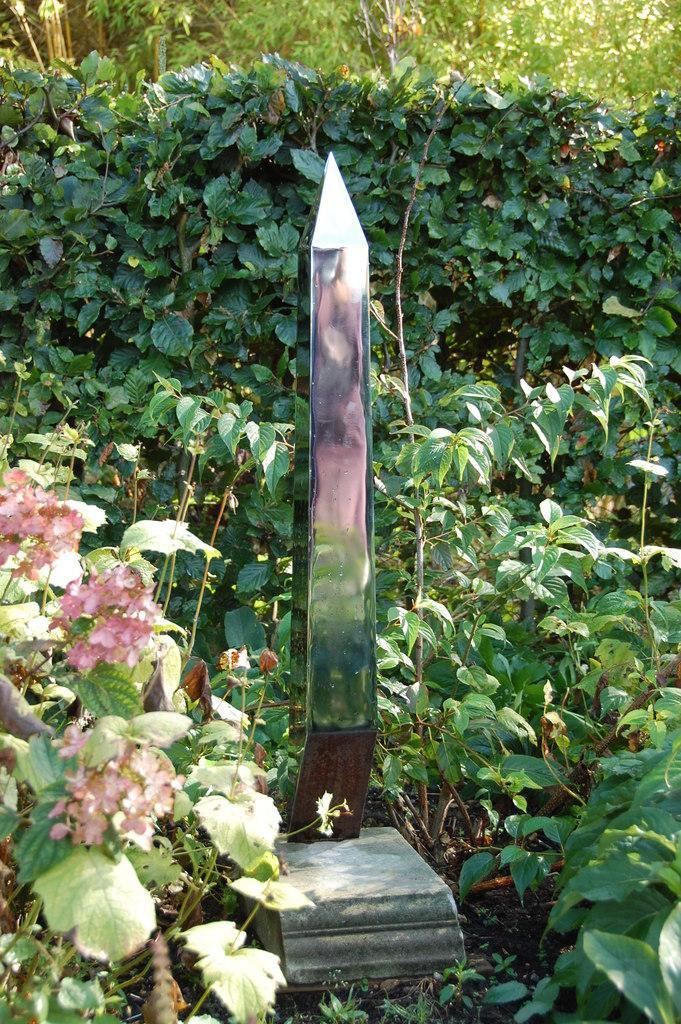In one or two sentences, can you explain what this image depicts? In this image there is a metal structure on the rock, which is on the surface, around that there are trees plants and flowers. 